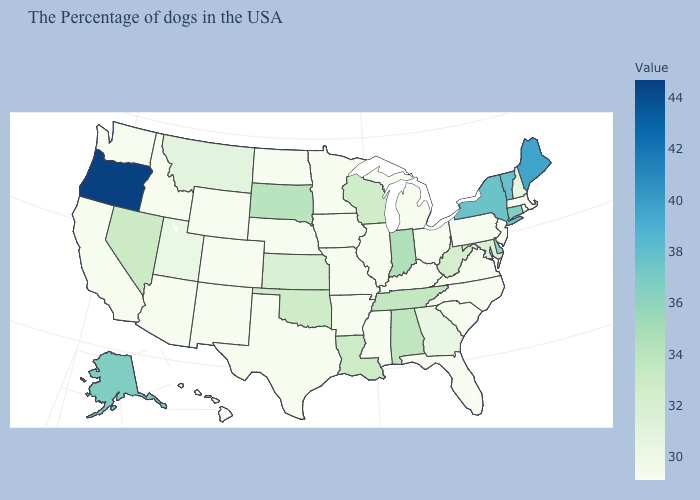Does Nevada have the lowest value in the West?
Answer briefly. No. Among the states that border Virginia , does Tennessee have the highest value?
Write a very short answer. Yes. Does Arizona have the lowest value in the USA?
Give a very brief answer. Yes. Among the states that border Missouri , which have the lowest value?
Write a very short answer. Kentucky, Illinois, Arkansas, Iowa, Nebraska. Which states hav the highest value in the West?
Short answer required. Oregon. Which states have the highest value in the USA?
Answer briefly. Oregon. Which states have the lowest value in the USA?
Write a very short answer. Massachusetts, Rhode Island, New Jersey, Pennsylvania, Virginia, North Carolina, South Carolina, Ohio, Florida, Michigan, Kentucky, Illinois, Mississippi, Missouri, Arkansas, Minnesota, Iowa, Nebraska, Texas, North Dakota, Wyoming, Colorado, New Mexico, Arizona, Idaho, California, Hawaii. Which states hav the highest value in the Northeast?
Answer briefly. Maine. 